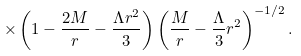<formula> <loc_0><loc_0><loc_500><loc_500>\times \left ( 1 - \frac { 2 M } { r } - \frac { \Lambda r ^ { 2 } } { 3 } \right ) \left ( \frac { M } { r } - \frac { \Lambda } { 3 } r ^ { 2 } \right ) ^ { - 1 / 2 } .</formula> 